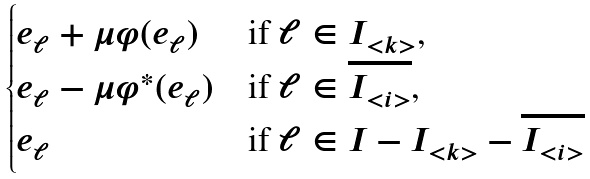Convert formula to latex. <formula><loc_0><loc_0><loc_500><loc_500>\begin{cases} e _ { \ell } + \mu \varphi ( e _ { \ell } ) & \text {if $\ell\in I_{<k>}$,} \\ e _ { \ell } - \mu \varphi ^ { * } ( e _ { \ell } ) & \text {if $\ell\in \overline{I_{<i>}}$,} \\ e _ { \ell } & \text {if $\ell\in I-I_{<k>}-\overline{I_{<i>}}$} \end{cases}</formula> 